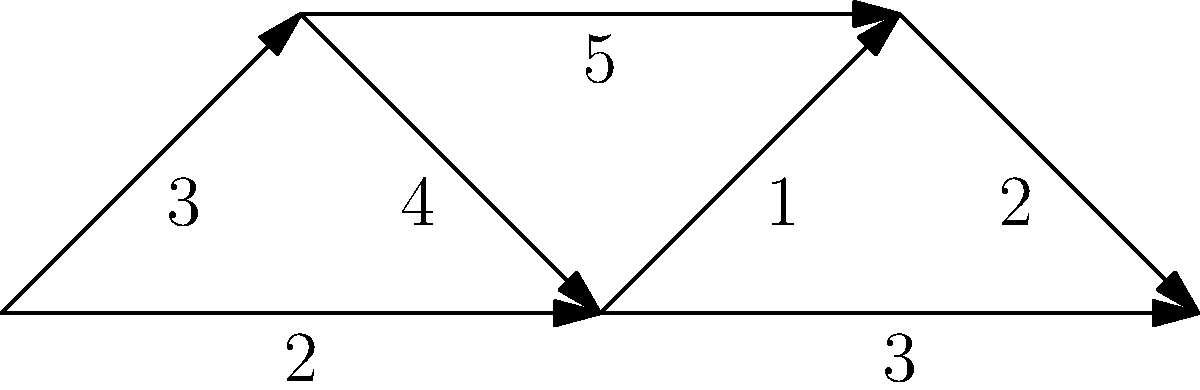In the network diagram representing the spread of an invasive plant species through various environments, what is the minimum number of environment transitions required for the species to spread from the Forest to the Urban area? To find the minimum number of environment transitions, we need to identify the shortest path from Forest to Urban in the weighted graph. Let's use Dijkstra's algorithm:

1. Initialize:
   - Forest: 0
   - All other nodes: infinity

2. From Forest:
   - To Grassland: 3
   - To River: 2 (shorter)

3. From River:
   - To Grassland: 2 + 4 = 6 (longer than direct)
   - To Wetland: 2 + 1 = 3
   - To Urban: 2 + 3 = 5

4. From Wetland:
   - To Urban: 3 + 2 = 5 (same as from River)

The shortest path is Forest → River → Urban, with a total weight of 5.

Each edge represents a transition between environments. The path Forest → River → Urban involves 2 transitions:
1. Forest to River
2. River to Urban

Therefore, the minimum number of environment transitions required is 2.
Answer: 2 